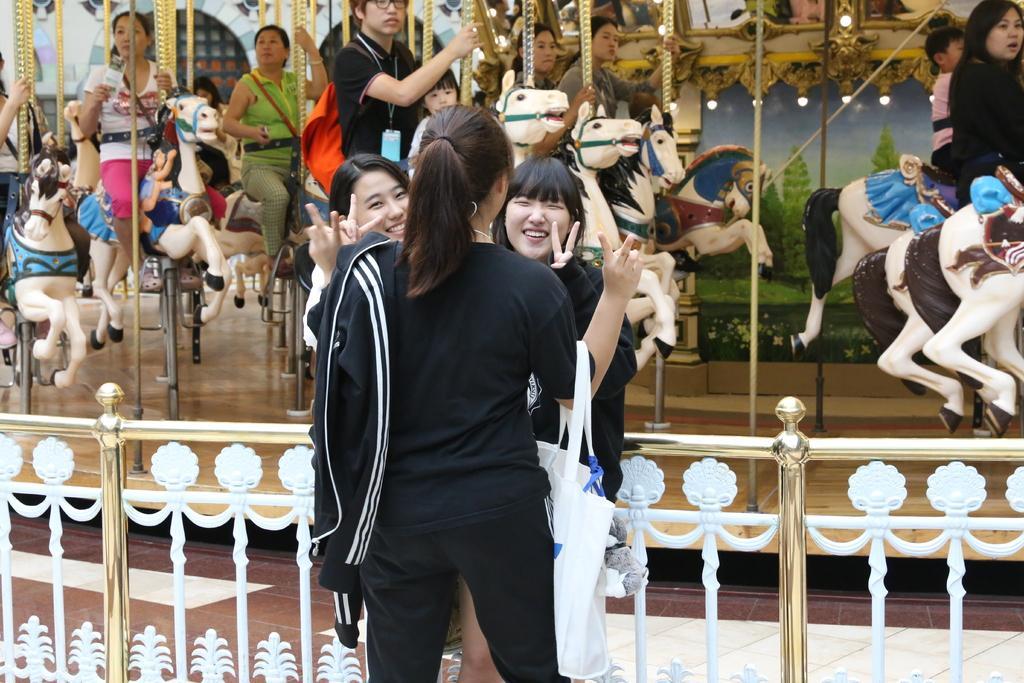How would you summarize this image in a sentence or two? In this image, I can see three persons standing. Behind the three persons, I can see railing. In the background, there are few people sitting on a carousel. 